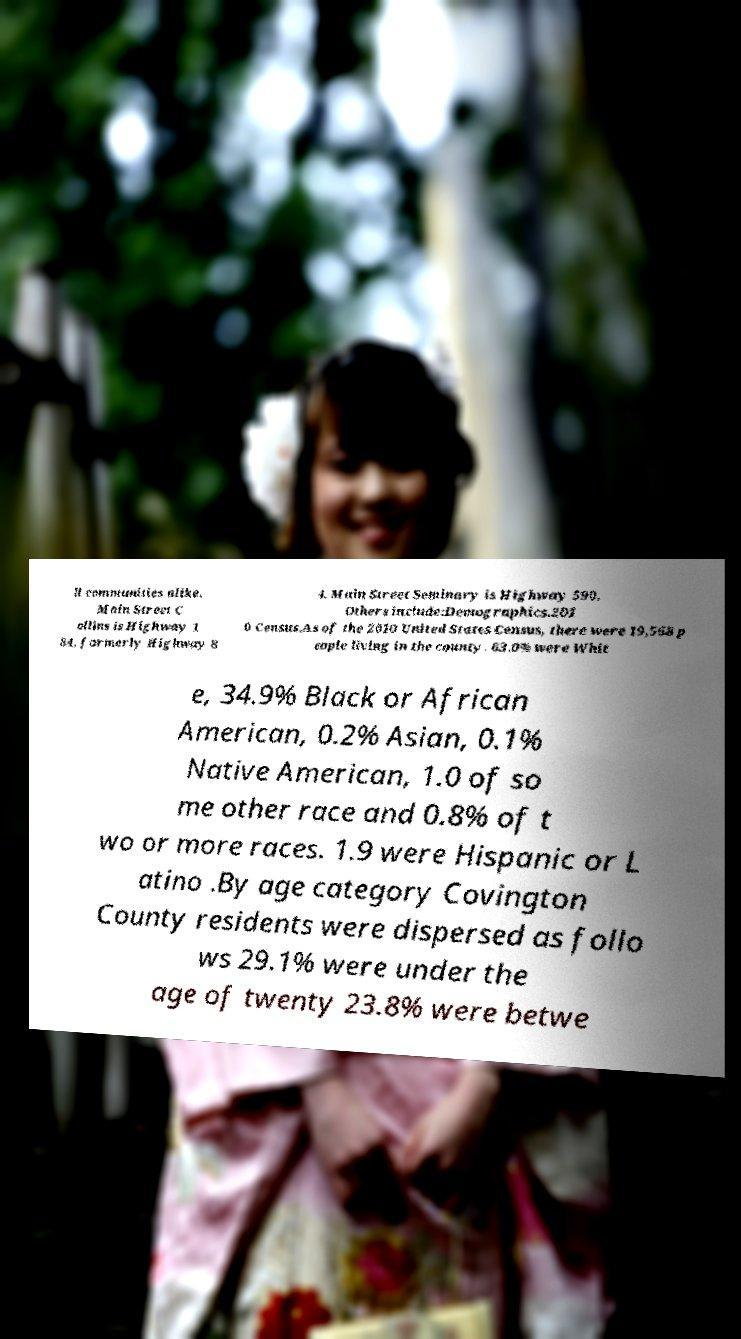What messages or text are displayed in this image? I need them in a readable, typed format. ll communities alike. Main Street C ollins is Highway 1 84, formerly Highway 8 4. Main Street Seminary is Highway 590. Others include:Demographics.201 0 Census.As of the 2010 United States Census, there were 19,568 p eople living in the county. 63.0% were Whit e, 34.9% Black or African American, 0.2% Asian, 0.1% Native American, 1.0 of so me other race and 0.8% of t wo or more races. 1.9 were Hispanic or L atino .By age category Covington County residents were dispersed as follo ws 29.1% were under the age of twenty 23.8% were betwe 